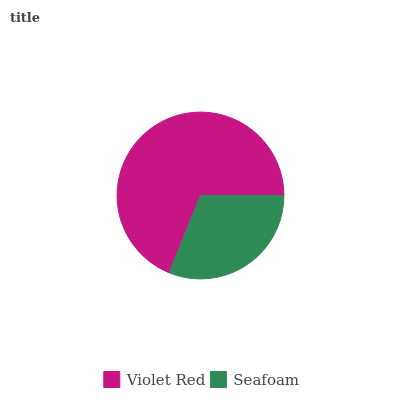Is Seafoam the minimum?
Answer yes or no. Yes. Is Violet Red the maximum?
Answer yes or no. Yes. Is Seafoam the maximum?
Answer yes or no. No. Is Violet Red greater than Seafoam?
Answer yes or no. Yes. Is Seafoam less than Violet Red?
Answer yes or no. Yes. Is Seafoam greater than Violet Red?
Answer yes or no. No. Is Violet Red less than Seafoam?
Answer yes or no. No. Is Violet Red the high median?
Answer yes or no. Yes. Is Seafoam the low median?
Answer yes or no. Yes. Is Seafoam the high median?
Answer yes or no. No. Is Violet Red the low median?
Answer yes or no. No. 